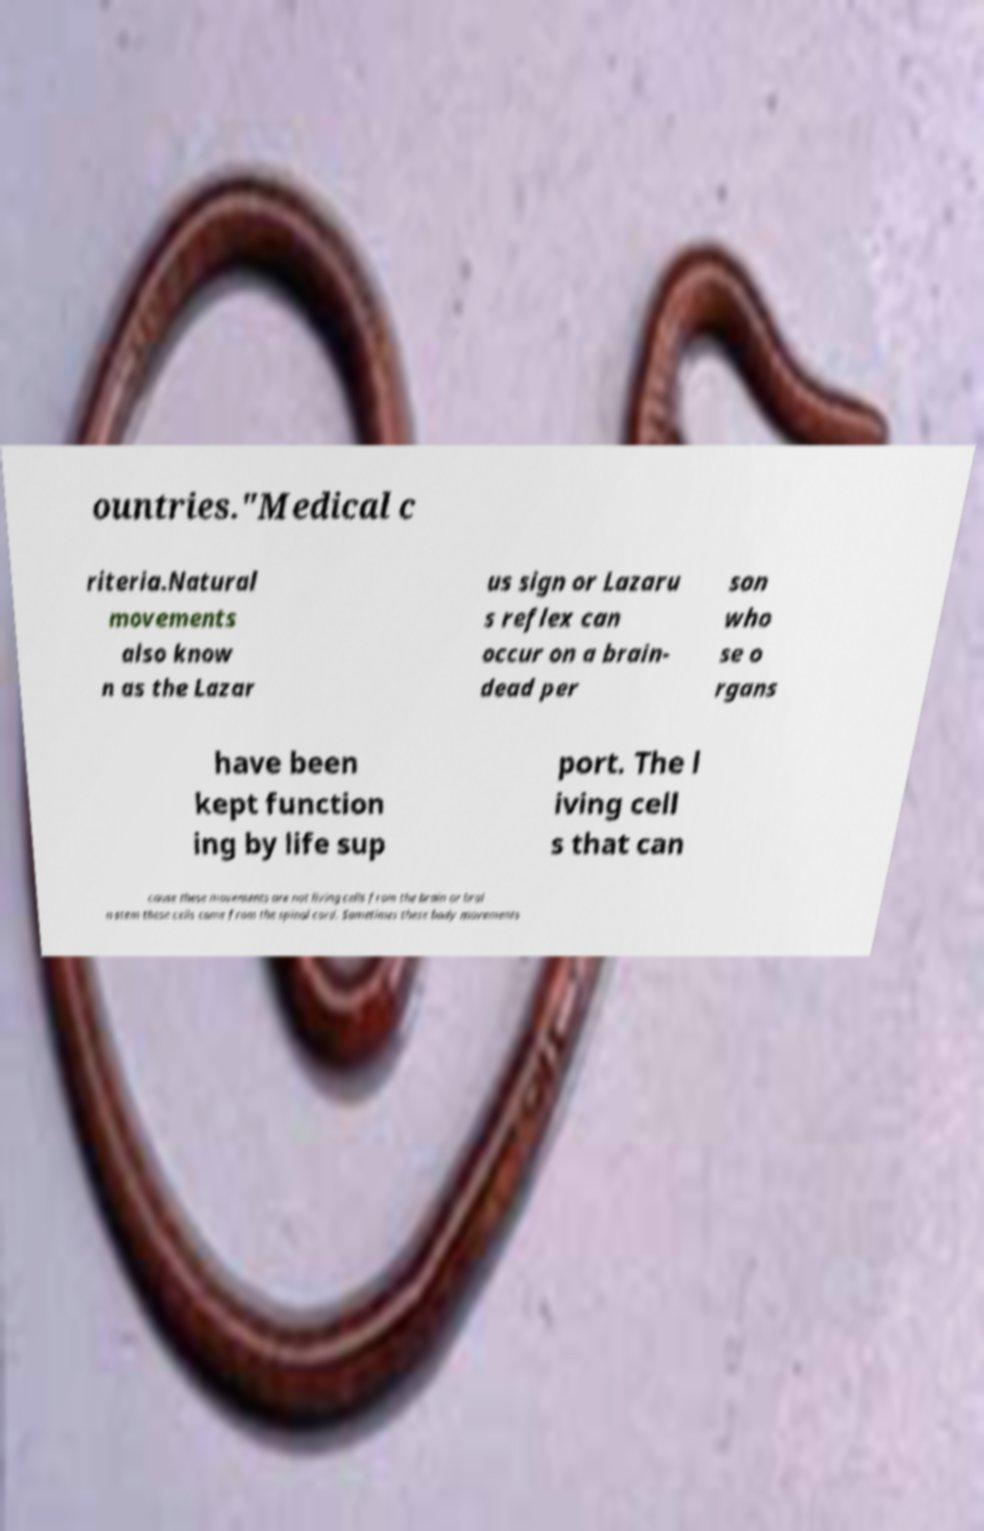Can you accurately transcribe the text from the provided image for me? ountries."Medical c riteria.Natural movements also know n as the Lazar us sign or Lazaru s reflex can occur on a brain- dead per son who se o rgans have been kept function ing by life sup port. The l iving cell s that can cause these movements are not living cells from the brain or brai n stem these cells come from the spinal cord. Sometimes these body movements 